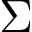<formula> <loc_0><loc_0><loc_500><loc_500>\Sigma</formula> 